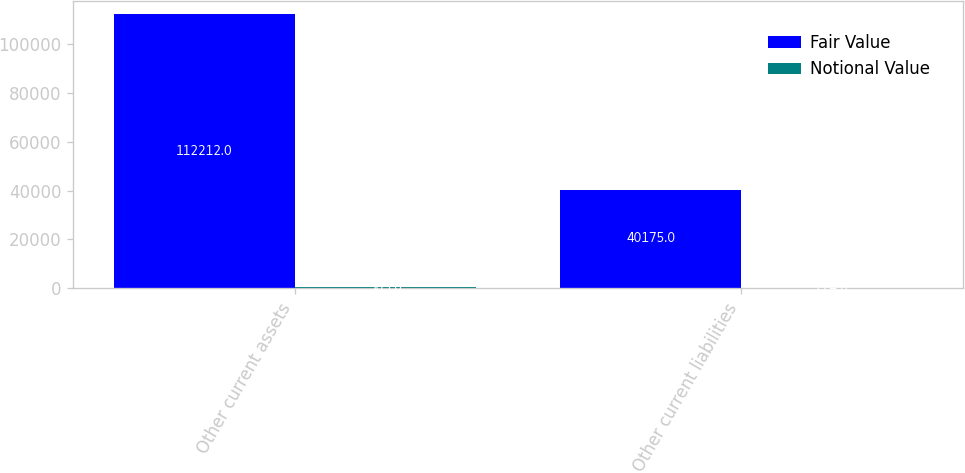Convert chart. <chart><loc_0><loc_0><loc_500><loc_500><stacked_bar_chart><ecel><fcel>Other current assets<fcel>Other current liabilities<nl><fcel>Fair Value<fcel>112212<fcel>40175<nl><fcel>Notional Value<fcel>503<fcel>224<nl></chart> 